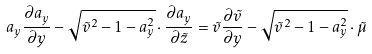Convert formula to latex. <formula><loc_0><loc_0><loc_500><loc_500>a _ { y } \frac { \partial { a _ { y } } } { \partial { y } } - \sqrt { \tilde { v } ^ { 2 } - 1 - a _ { y } ^ { 2 } } \cdot \frac { \partial { a _ { y } } } { \partial { \tilde { z } } } = \tilde { v } \frac { \partial { \tilde { v } } } { \partial { y } } - \sqrt { \tilde { v } ^ { 2 } - 1 - a _ { y } ^ { 2 } } \cdot \tilde { \mu }</formula> 